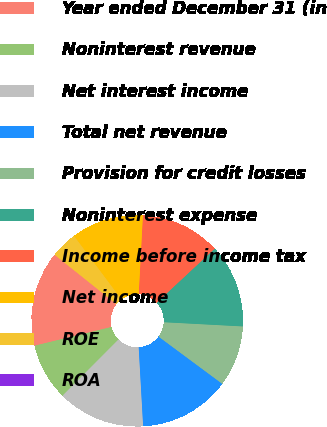Convert chart to OTSL. <chart><loc_0><loc_0><loc_500><loc_500><pie_chart><fcel>Year ended December 31 (in<fcel>Noninterest revenue<fcel>Net interest income<fcel>Total net revenue<fcel>Provision for credit losses<fcel>Noninterest expense<fcel>Income before income tax<fcel>Net income<fcel>ROE<fcel>ROA<nl><fcel>14.53%<fcel>8.72%<fcel>13.37%<fcel>13.95%<fcel>9.3%<fcel>12.79%<fcel>12.21%<fcel>11.05%<fcel>4.07%<fcel>0.0%<nl></chart> 